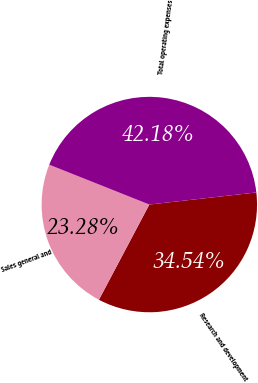Convert chart to OTSL. <chart><loc_0><loc_0><loc_500><loc_500><pie_chart><fcel>Research and development<fcel>Sales general and<fcel>Total operating expenses<nl><fcel>34.54%<fcel>23.28%<fcel>42.18%<nl></chart> 